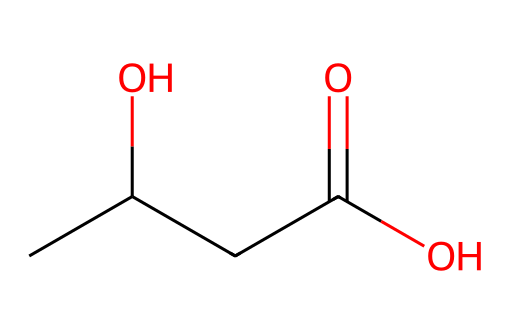How many carbon atoms are in beta-hydroxybutyrate? The SMILES representation shows "CC(O)CC(=O)O," which can be translated to the carbon chain and the functional groups. Counting the "C" symbols results in a total of four carbon atoms.
Answer: four What are the functional groups present in beta-hydroxybutyrate? Analyzing the SMILES string reveals the presence of a hydroxyl group (-OH), a ketone group (=O), and a carboxylic acid group (-COOH). These can be identified by looking for "O" connected to carbon atoms and specific bonding patterns.
Answer: hydroxyl, ketone, carboxylic acid What is the molecular formula of beta-hydroxybutyrate? The carbon (C), hydrogen (H), and oxygen (O) atoms can be counted directly from the SMILES string. There are four carbons, eight hydrogens, and three oxygens, leading to the formula C4H8O3.
Answer: C4H8O3 Which part of the molecule indicates it is a ketone? The structure has a carbonyl group (C=O) which is characteristic of ketones; in this case, it is connected to a carbon chain. Examining the functional groups shows that the ketone is part of the main carbon chain.
Answer: C=O How does the presence of a hydroxyl group affect the polarity of beta-hydroxybutyrate? The hydroxyl group (-OH) increases the polarity of the molecule due to the ability of oxygen to engage in hydrogen bonding, which is critical for solubility in water. The presence of the -OH adds significant polar character.
Answer: increases polarity Is beta-hydroxybutyrate an important energy source during ketosis? Yes, beta-hydroxybutyrate acts as a primary ketone body that provides energy during states of low carbohydrate availability, such as fasting or low-carb diets. It is significant because it serves as an alternative fuel for the brain and other tissues.
Answer: yes 